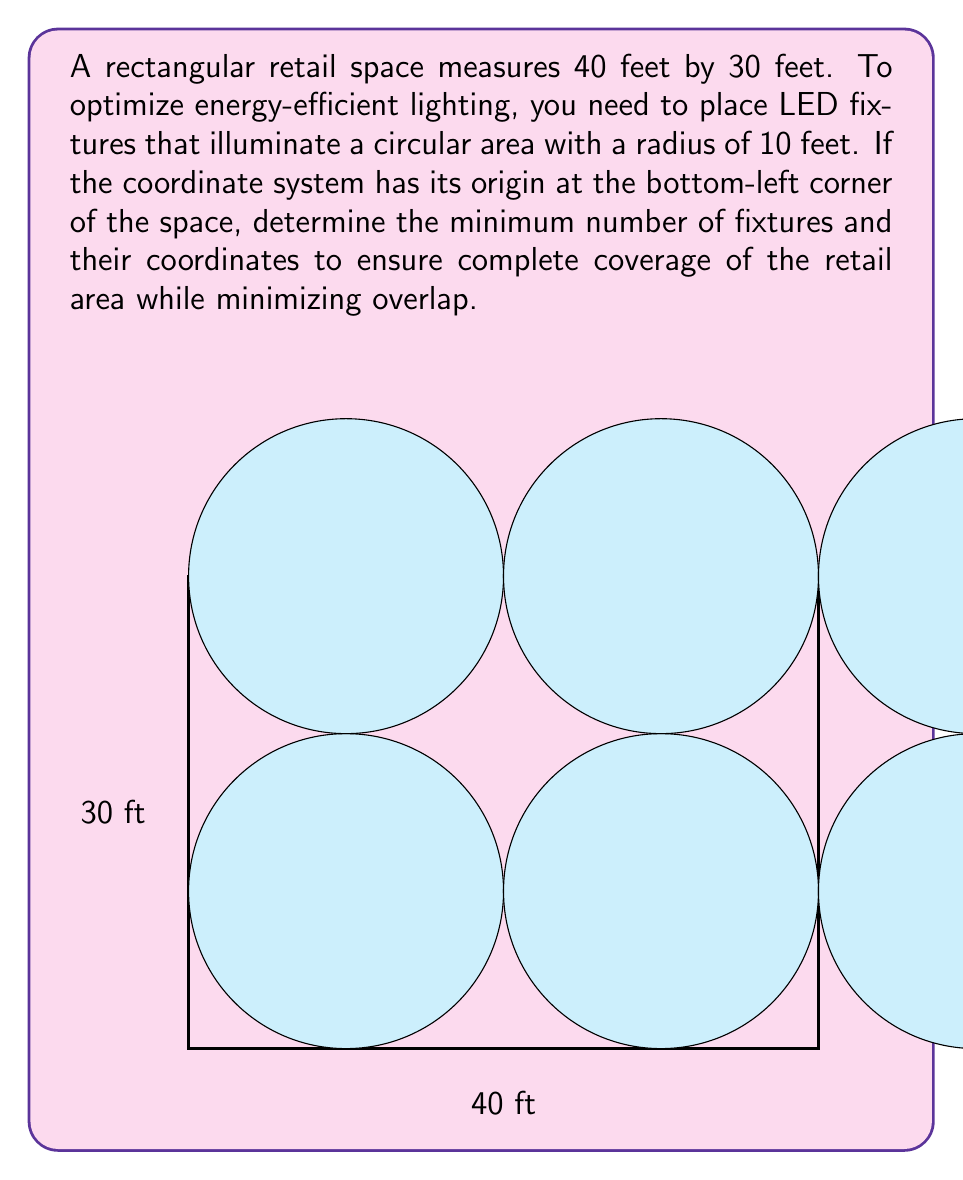Provide a solution to this math problem. To solve this problem, we'll follow these steps:

1) First, we need to determine the optimal placement of the fixtures. The most efficient arrangement is to place them in a grid pattern.

2) Given the circular illumination area, we can calculate the maximum distance between fixture centers:
   $$2 \times 10 \text{ ft} = 20 \text{ ft}$$

3) For the 40-foot length:
   $$\text{Number of fixtures along length} = \lceil 40 \text{ ft} / 20 \text{ ft} \rceil = 3$$

4) For the 30-foot width:
   $$\text{Number of fixtures along width} = \lceil 30 \text{ ft} / 20 \text{ ft} \rceil = 2$$

5) Total number of fixtures:
   $$3 \times 2 = 6 \text{ fixtures}$$

6) To calculate the coordinates, we'll center the fixtures in each 20 ft by 20 ft section:

   Row 1 (y = 10):
   $$(10, 10), (30, 10)$$

   Row 2 (y = 30):
   $$(10, 30), (30, 30)$$

   Row 3 (x = 20):
   $$(20, 10), (20, 30)$$

This arrangement ensures complete coverage with minimal overlap.
Answer: 6 fixtures at coordinates: $(10, 10)$, $(30, 10)$, $(10, 30)$, $(30, 30)$, $(20, 10)$, $(20, 30)$ 